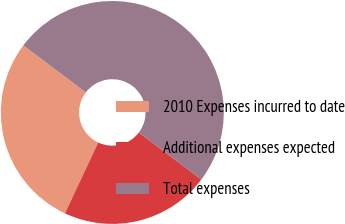Convert chart. <chart><loc_0><loc_0><loc_500><loc_500><pie_chart><fcel>2010 Expenses incurred to date<fcel>Additional expenses expected<fcel>Total expenses<nl><fcel>28.29%<fcel>21.71%<fcel>50.0%<nl></chart> 